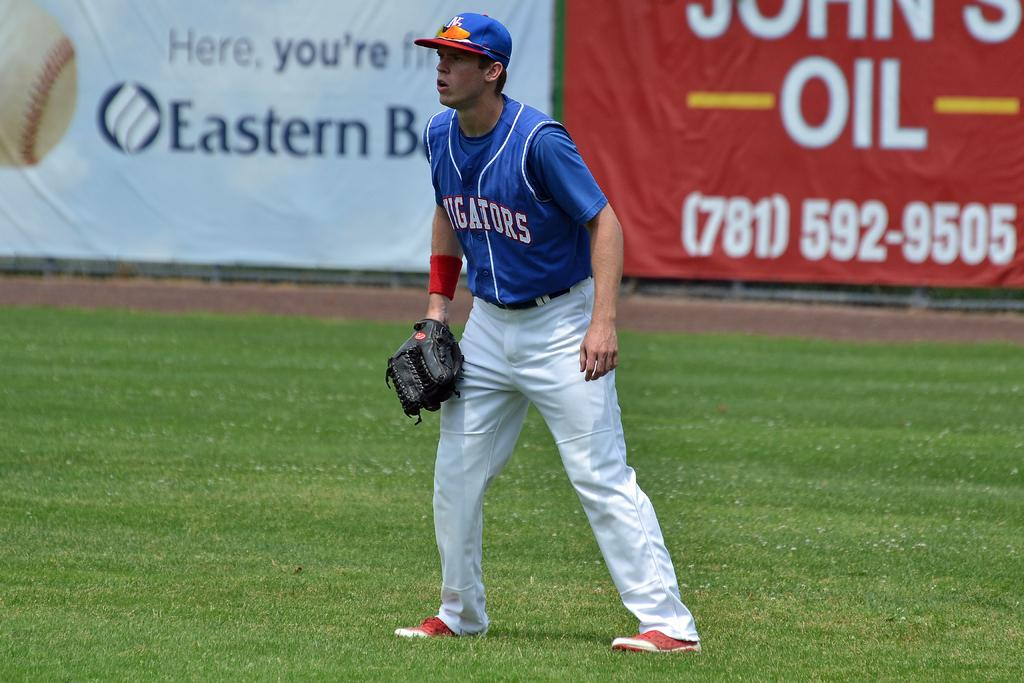<image>
Give a short and clear explanation of the subsequent image. A person wearing a blue jersey with the word alligators on the front 